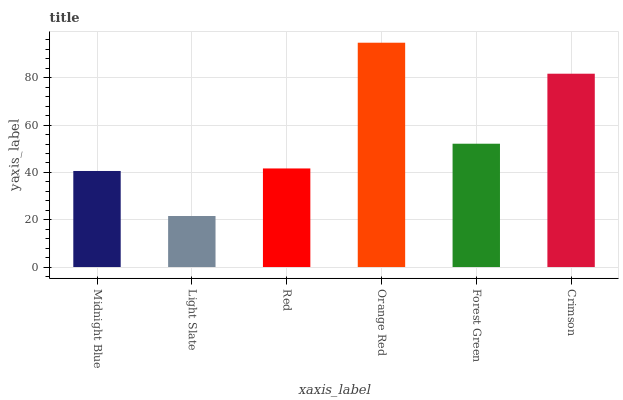Is Light Slate the minimum?
Answer yes or no. Yes. Is Orange Red the maximum?
Answer yes or no. Yes. Is Red the minimum?
Answer yes or no. No. Is Red the maximum?
Answer yes or no. No. Is Red greater than Light Slate?
Answer yes or no. Yes. Is Light Slate less than Red?
Answer yes or no. Yes. Is Light Slate greater than Red?
Answer yes or no. No. Is Red less than Light Slate?
Answer yes or no. No. Is Forest Green the high median?
Answer yes or no. Yes. Is Red the low median?
Answer yes or no. Yes. Is Orange Red the high median?
Answer yes or no. No. Is Light Slate the low median?
Answer yes or no. No. 